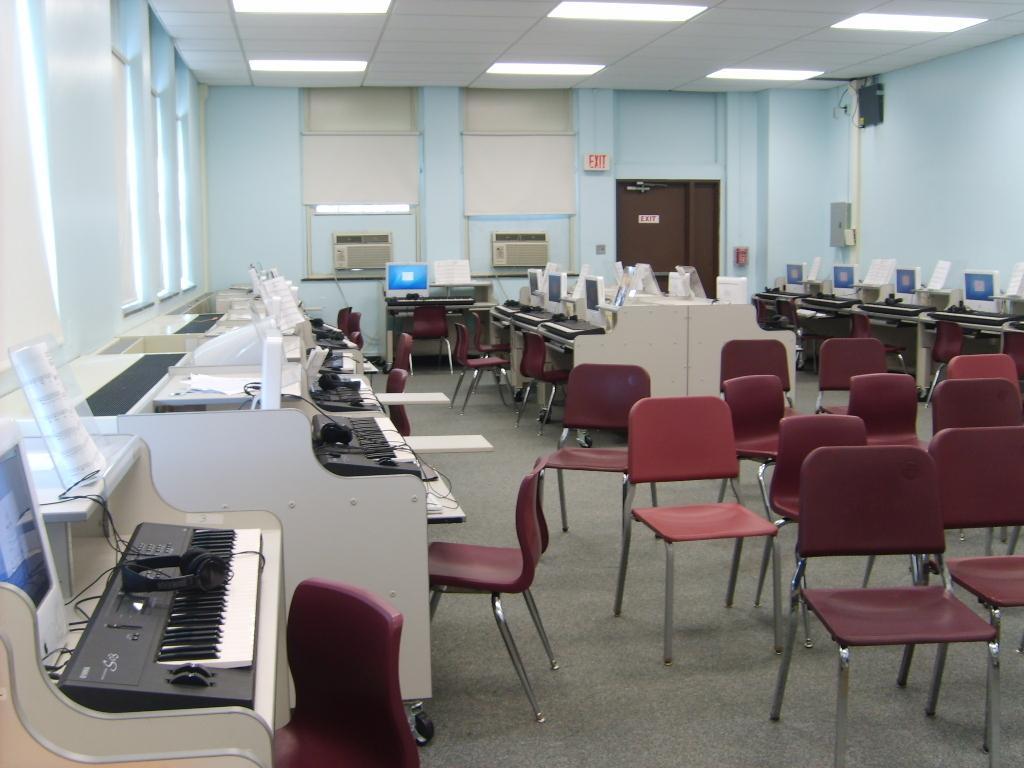In one or two sentences, can you explain what this image depicts? This image describes about a room in this room we can see a piano on the table, and also we can see some chairs, in the background we can see monitors pianos on the table. 